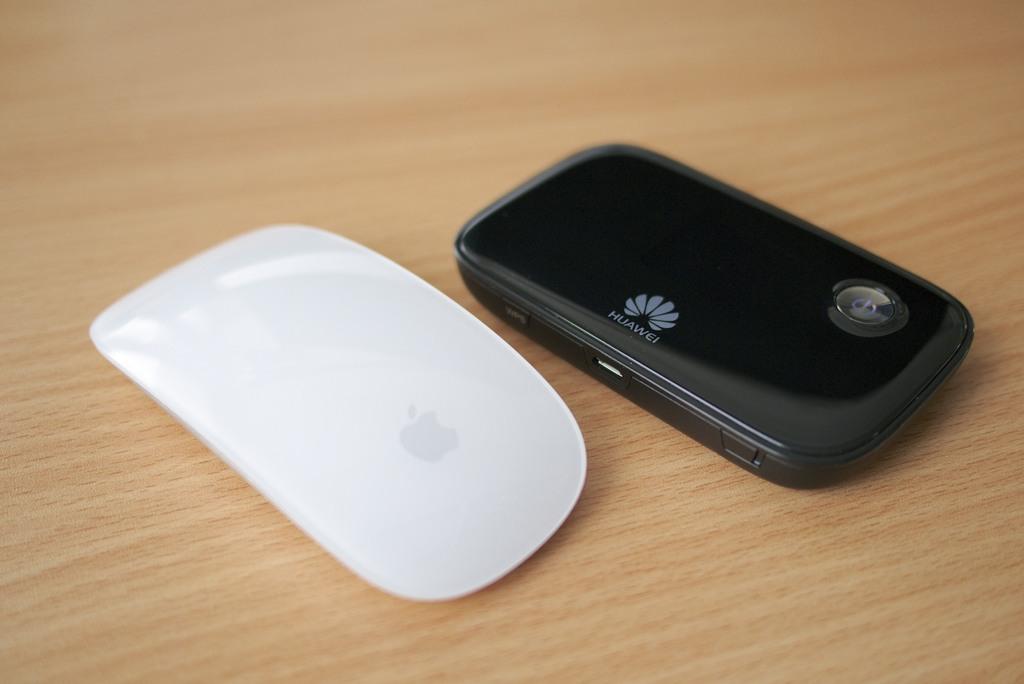What brand is this phone?
Ensure brevity in your answer.  Huawei. What is the first letter of the brand?
Keep it short and to the point. H. 